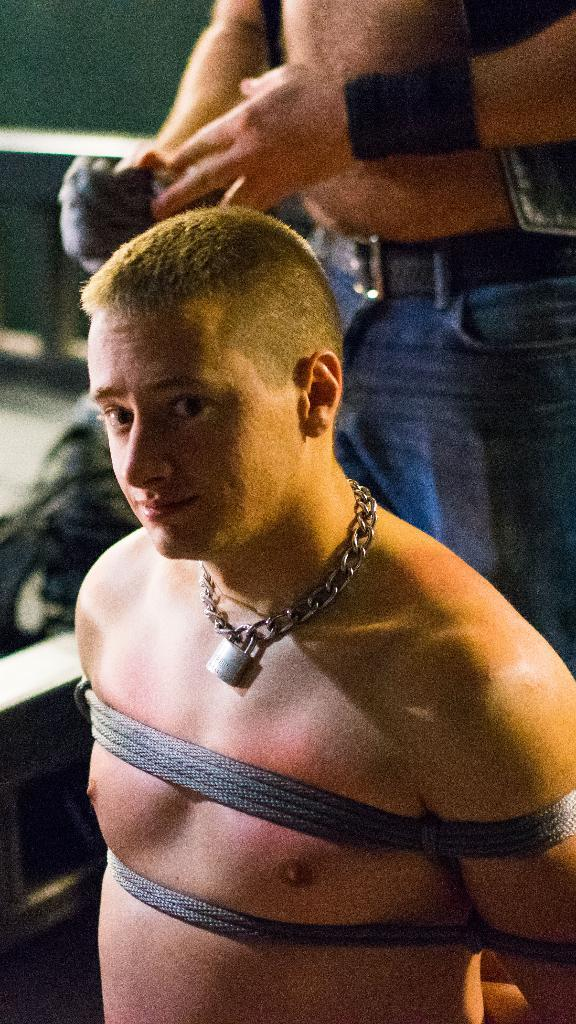How many people are present in the image? There are two people in the image. Can you describe the background of the image? There is a wall in the background of the image. What type of stick is being used by one of the people in the image? There is no stick present in the image; only two people and a wall are visible. 